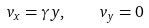<formula> <loc_0><loc_0><loc_500><loc_500>v _ { x } = \gamma y , \quad v _ { y } = 0</formula> 